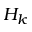<formula> <loc_0><loc_0><loc_500><loc_500>H _ { k }</formula> 